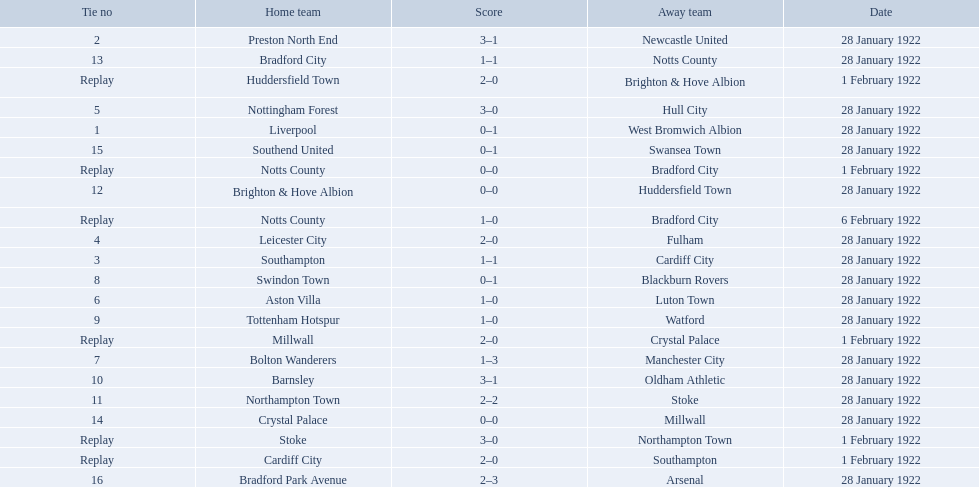What was the score in the aston villa game? 1–0. Which other team had an identical score? Tottenham Hotspur. 